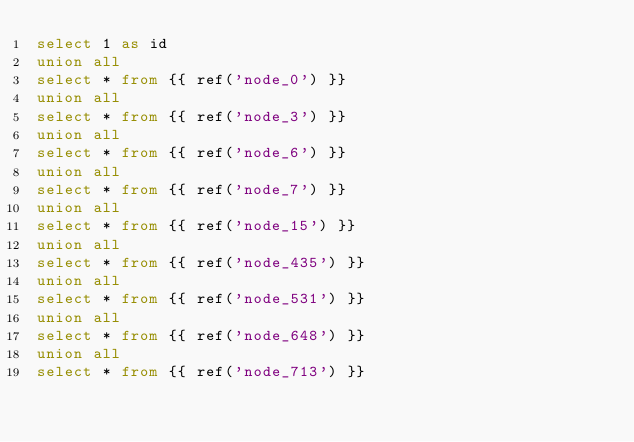Convert code to text. <code><loc_0><loc_0><loc_500><loc_500><_SQL_>select 1 as id
union all
select * from {{ ref('node_0') }}
union all
select * from {{ ref('node_3') }}
union all
select * from {{ ref('node_6') }}
union all
select * from {{ ref('node_7') }}
union all
select * from {{ ref('node_15') }}
union all
select * from {{ ref('node_435') }}
union all
select * from {{ ref('node_531') }}
union all
select * from {{ ref('node_648') }}
union all
select * from {{ ref('node_713') }}</code> 